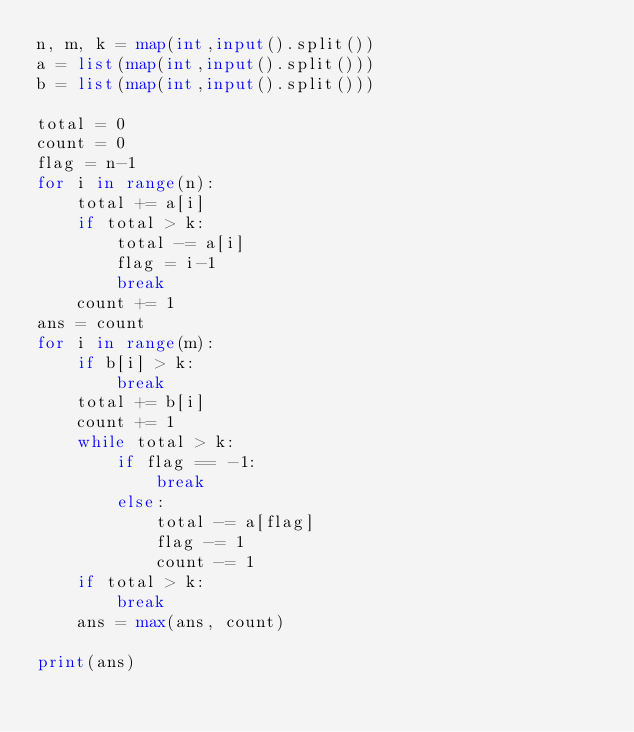<code> <loc_0><loc_0><loc_500><loc_500><_Python_>n, m, k = map(int,input().split())
a = list(map(int,input().split()))
b = list(map(int,input().split()))

total = 0
count = 0
flag = n-1
for i in range(n):
    total += a[i]
    if total > k:
        total -= a[i]
        flag = i-1
        break
    count += 1
ans = count
for i in range(m):
    if b[i] > k:
        break
    total += b[i]
    count += 1
    while total > k:
        if flag == -1:
            break
        else:
            total -= a[flag]
            flag -= 1
            count -= 1
    if total > k: 
        break
    ans = max(ans, count)

print(ans)</code> 